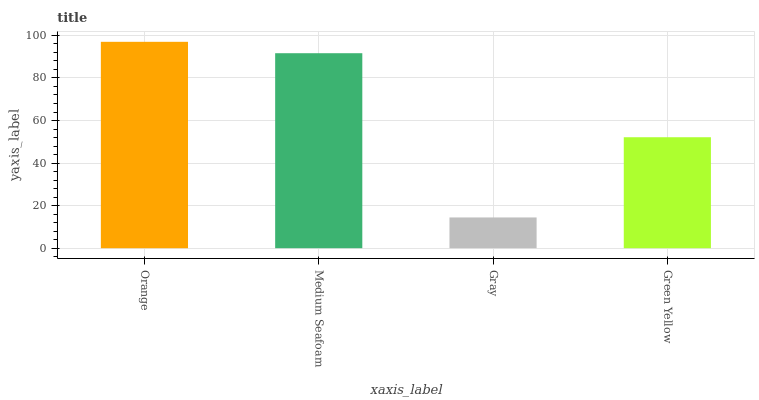Is Gray the minimum?
Answer yes or no. Yes. Is Orange the maximum?
Answer yes or no. Yes. Is Medium Seafoam the minimum?
Answer yes or no. No. Is Medium Seafoam the maximum?
Answer yes or no. No. Is Orange greater than Medium Seafoam?
Answer yes or no. Yes. Is Medium Seafoam less than Orange?
Answer yes or no. Yes. Is Medium Seafoam greater than Orange?
Answer yes or no. No. Is Orange less than Medium Seafoam?
Answer yes or no. No. Is Medium Seafoam the high median?
Answer yes or no. Yes. Is Green Yellow the low median?
Answer yes or no. Yes. Is Green Yellow the high median?
Answer yes or no. No. Is Medium Seafoam the low median?
Answer yes or no. No. 